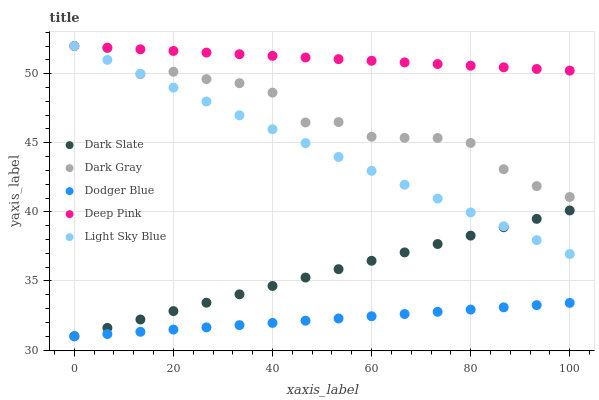Does Dodger Blue have the minimum area under the curve?
Answer yes or no. Yes. Does Deep Pink have the maximum area under the curve?
Answer yes or no. Yes. Does Dark Slate have the minimum area under the curve?
Answer yes or no. No. Does Dark Slate have the maximum area under the curve?
Answer yes or no. No. Is Dodger Blue the smoothest?
Answer yes or no. Yes. Is Dark Gray the roughest?
Answer yes or no. Yes. Is Dark Slate the smoothest?
Answer yes or no. No. Is Dark Slate the roughest?
Answer yes or no. No. Does Dark Slate have the lowest value?
Answer yes or no. Yes. Does Deep Pink have the lowest value?
Answer yes or no. No. Does Light Sky Blue have the highest value?
Answer yes or no. Yes. Does Dark Slate have the highest value?
Answer yes or no. No. Is Dodger Blue less than Dark Gray?
Answer yes or no. Yes. Is Light Sky Blue greater than Dodger Blue?
Answer yes or no. Yes. Does Dark Gray intersect Deep Pink?
Answer yes or no. Yes. Is Dark Gray less than Deep Pink?
Answer yes or no. No. Is Dark Gray greater than Deep Pink?
Answer yes or no. No. Does Dodger Blue intersect Dark Gray?
Answer yes or no. No. 